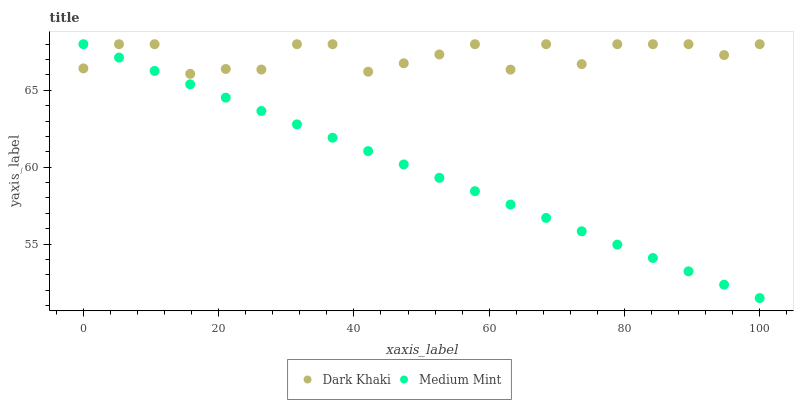Does Medium Mint have the minimum area under the curve?
Answer yes or no. Yes. Does Dark Khaki have the maximum area under the curve?
Answer yes or no. Yes. Does Medium Mint have the maximum area under the curve?
Answer yes or no. No. Is Medium Mint the smoothest?
Answer yes or no. Yes. Is Dark Khaki the roughest?
Answer yes or no. Yes. Is Medium Mint the roughest?
Answer yes or no. No. Does Medium Mint have the lowest value?
Answer yes or no. Yes. Does Medium Mint have the highest value?
Answer yes or no. Yes. Does Dark Khaki intersect Medium Mint?
Answer yes or no. Yes. Is Dark Khaki less than Medium Mint?
Answer yes or no. No. Is Dark Khaki greater than Medium Mint?
Answer yes or no. No. 